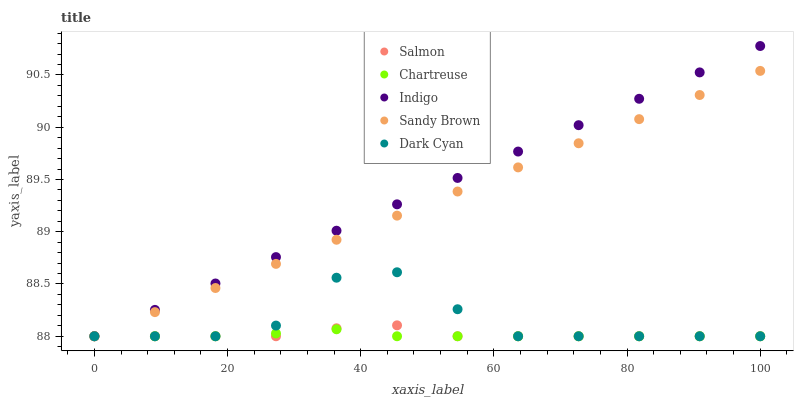Does Chartreuse have the minimum area under the curve?
Answer yes or no. Yes. Does Indigo have the maximum area under the curve?
Answer yes or no. Yes. Does Indigo have the minimum area under the curve?
Answer yes or no. No. Does Chartreuse have the maximum area under the curve?
Answer yes or no. No. Is Indigo the smoothest?
Answer yes or no. Yes. Is Dark Cyan the roughest?
Answer yes or no. Yes. Is Chartreuse the smoothest?
Answer yes or no. No. Is Chartreuse the roughest?
Answer yes or no. No. Does Dark Cyan have the lowest value?
Answer yes or no. Yes. Does Indigo have the highest value?
Answer yes or no. Yes. Does Chartreuse have the highest value?
Answer yes or no. No. Does Dark Cyan intersect Indigo?
Answer yes or no. Yes. Is Dark Cyan less than Indigo?
Answer yes or no. No. Is Dark Cyan greater than Indigo?
Answer yes or no. No. 